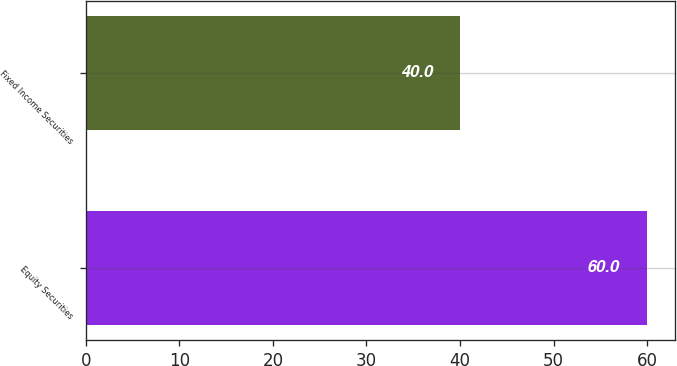Convert chart to OTSL. <chart><loc_0><loc_0><loc_500><loc_500><bar_chart><fcel>Equity Securities<fcel>Fixed Income Securities<nl><fcel>60<fcel>40<nl></chart> 